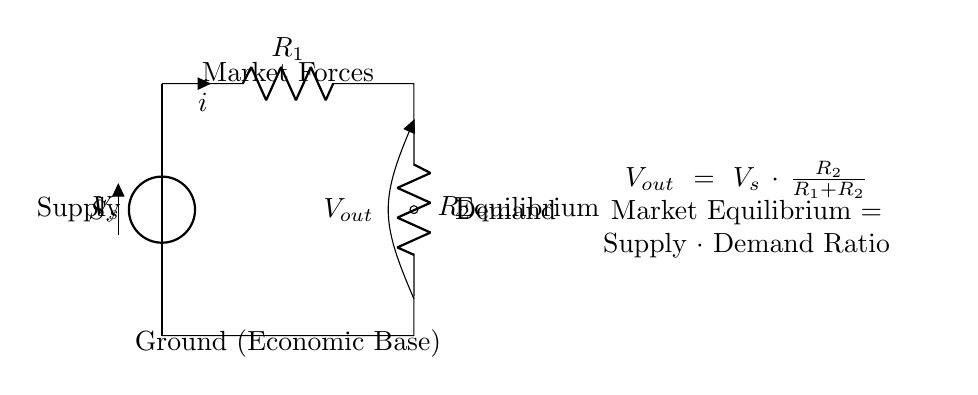What is the supply voltage in the circuit? The supply voltage, labeled as \( V_s \), represents the market supply and is located at the top of the circuit diagram where the voltage source is depicted.
Answer: \( V_s \) What are the names of the two resistors in the circuit? The two resistors in the circuit are labeled as \( R_1 \) and \( R_2 \), which represent the market forces impacting supply and demand.
Answer: \( R_1 \) and \( R_2 \) Where is the output voltage measured in the circuit? The output voltage, labeled \( V_{out} \), is measured across the two resistors as indicated at the bottom right of the circuit where the open terminal is shown.
Answer: At the output terminal What formula represents the market equilibrium in this circuit? The formula is provided in the diagram as \( V_{out} = V_s \cdot \frac{R_2}{R_1 + R_2} \) which explains how the output relates to the supply and demand ratio.
Answer: \( V_{out} = V_s \cdot \frac{R_2}{R_1 + R_2} \) What does the equilibrium point signify in the circuit? The equilibrium point is where the supply matches demand, represented by the dot in the diagram where \( V_{out} \) is located, denoting the balance in the market.
Answer: Market Equilibrium How does increasing \( R_2 \) affect \( V_{out} \)? Increasing \( R_2 \) increases the output voltage \( V_{out} \) based on the voltage divider rule, as it increases the proportion of \( V_s \) across \( R_2 \) when kept constant with \( R_1 \).
Answer: Increases \( V_{out} \) What happens to the output voltage when \( R_1 \) is much larger than \( R_2 \)? When \( R_1 \) is much larger than \( R_2 \), the output voltage \( V_{out} \) approaches zero, as the ratio \( \frac{R_2}{R_1 + R_2} \) becomes very small, leading to little to no voltage drop across \( R_2 \).
Answer: Approaches zero 